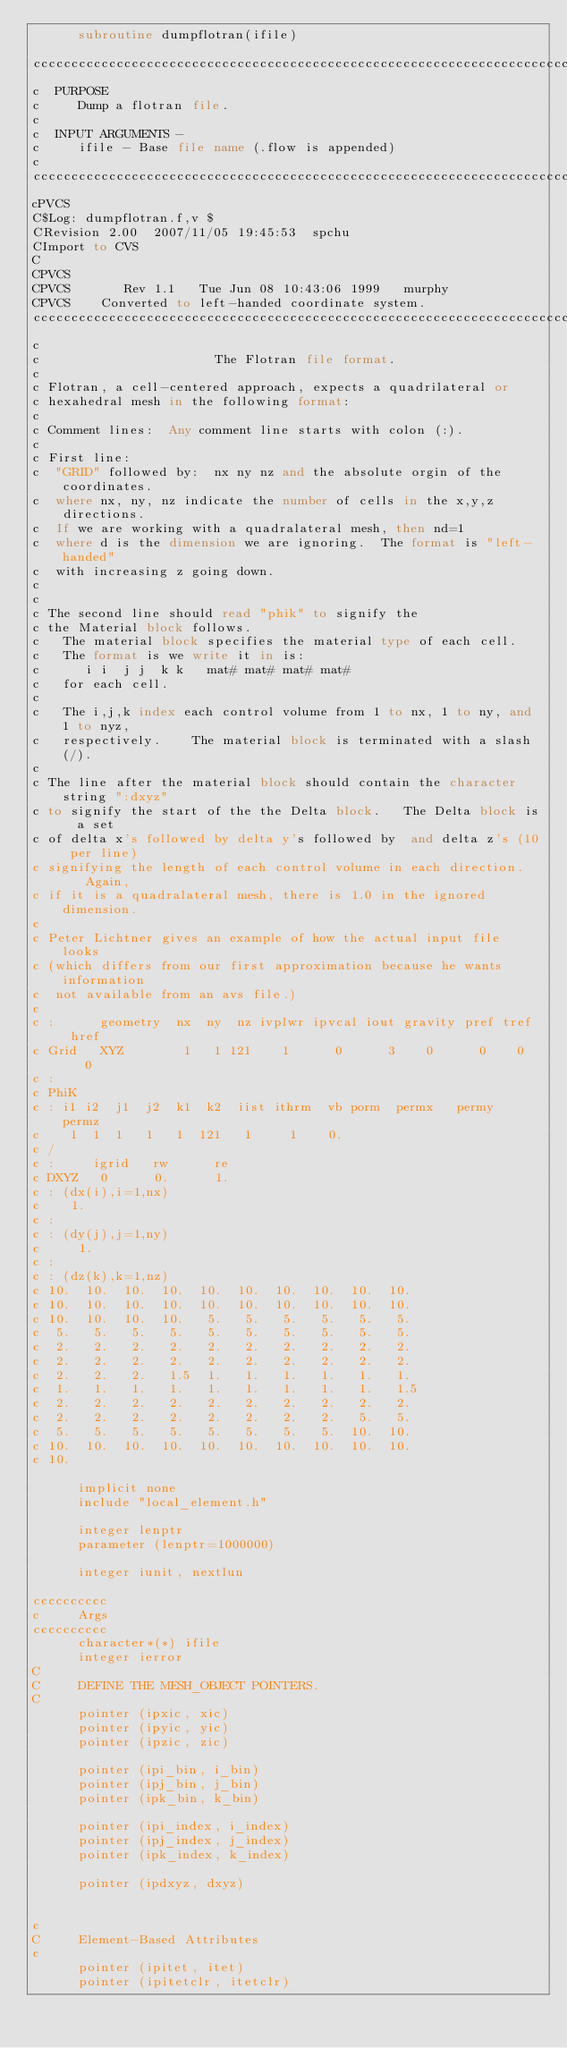<code> <loc_0><loc_0><loc_500><loc_500><_FORTRAN_>      subroutine dumpflotran(ifile)

ccccccccccccccccccccccccccccccccccccccccccccccccccccccccccccccccccccccccc
c  PURPOSE
c     Dump a flotran file.
c
c  INPUT ARGUMENTS - 
c     ifile - Base file name (.flow is appended)
c
ccccccccccccccccccccccccccccccccccccccccccccccccccccccccccccccccccccccccccccc
cPVCS
C$Log: dumpflotran.f,v $
CRevision 2.00  2007/11/05 19:45:53  spchu
CImport to CVS
C
CPVCS    
CPVCS       Rev 1.1   Tue Jun 08 10:43:06 1999   murphy
CPVCS    Converted to left-handed coordinate system.
ccccccccccccccccccccccccccccccccccccccccccccccccccccccccccccccccccccccccccccc
c
c                       The Flotran file format.
c
c Flotran, a cell-centered approach, expects a quadrilateral or 
c hexahedral mesh in the following format: 
c
c Comment lines:  Any comment line starts with colon (:).   
c
c First line: 
c  "GRID" followed by:  nx ny nz and the absolute orgin of the coordinates.  
c  where nx, ny, nz indicate the number of cells in the x,y,z directions.
c  If we are working with a quadralateral mesh, then nd=1
c  where d is the dimension we are ignoring.  The format is "left-handed"
c  with increasing z going down.
c
c
c The second line should read "phik" to signify the 
c the Material block follows.  
c   The material block specifies the material type of each cell. 
c   The format is we write it in is:
c      i i  j j  k k   mat# mat# mat# mat# 
c   for each cell.  
c
c   The i,j,k index each control volume from 1 to nx, 1 to ny, and 1 to nyz,
c   respectively.    The material block is terminated with a slash (/).  
c
c The line after the material block should contain the character string ":dxyz"
c to signify the start of the the Delta block.   The Delta block is  a set 
c of delta x's followed by delta y's followed by  and delta z's (10 per line)
c signifying the length of each control volume in each direction.    Again,
c if it is a quadralateral mesh, there is 1.0 in the ignored dimension.  
c
c Peter Lichtner gives an example of how the actual input file looks 
c (which differs from our first approximation because he wants information
c  not available from an avs file.)
c
c :      geometry  nx  ny  nz ivplwr ipvcal iout gravity pref tref  href
c Grid   XYZ        1   1 121    1      0      3    0      0    0    0
c :
c PhiK
c : i1 i2  j1  j2  k1  k2  iist ithrm  vb porm  permx   permy    permz
c    1  1  1   1   1  121   1     1    0.
c /
c :     igrid   rw      re
c DXYZ   0      0.      1.
c : (dx(i),i=1,nx)
c    1.
c :
c : (dy(j),j=1,ny)
c     1.
c :
c : (dz(k),k=1,nz)
c 10.  10.  10.  10.  10.  10.  10.  10.  10.  10.
c 10.  10.  10.  10.  10.  10.  10.  10.  10.  10.
c 10.  10.  10.  10.   5.   5.   5.   5.   5.   5.
c  5.   5.   5.   5.   5.   5.   5.   5.   5.   5.
c  2.   2.   2.   2.   2.   2.   2.   2.   2.   2.
c  2.   2.   2.   2.   2.   2.   2.   2.   2.   2.
c  2.   2.   2.   1.5  1.   1.   1.   1.   1.   1.
c  1.   1.   1.   1.   1.   1.   1.   1.   1.   1.5
c  2.   2.   2.   2.   2.   2.   2.   2.   2.   2.
c  2.   2.   2.   2.   2.   2.   2.   2.   5.   5.
c  5.   5.   5.   5.   5.   5.   5.   5.  10.  10.
c 10.  10.  10.  10.  10.  10.  10.  10.  10.  10.
c 10.

      implicit none
      include "local_element.h"

      integer lenptr
      parameter (lenptr=1000000)

      integer iunit, nextlun

cccccccccc
c     Args
cccccccccc
      character*(*) ifile
      integer ierror
C
C     DEFINE THE MESH_OBJECT POINTERS.
C
      pointer (ipxic, xic)
      pointer (ipyic, yic)
      pointer (ipzic, zic)

      pointer (ipi_bin, i_bin)
      pointer (ipj_bin, j_bin)
      pointer (ipk_bin, k_bin)

      pointer (ipi_index, i_index)
      pointer (ipj_index, j_index)
      pointer (ipk_index, k_index)

      pointer (ipdxyz, dxyz)


c 
C     Element-Based Attributes
c
      pointer (ipitet, itet)
      pointer (ipitetclr, itetclr)</code> 